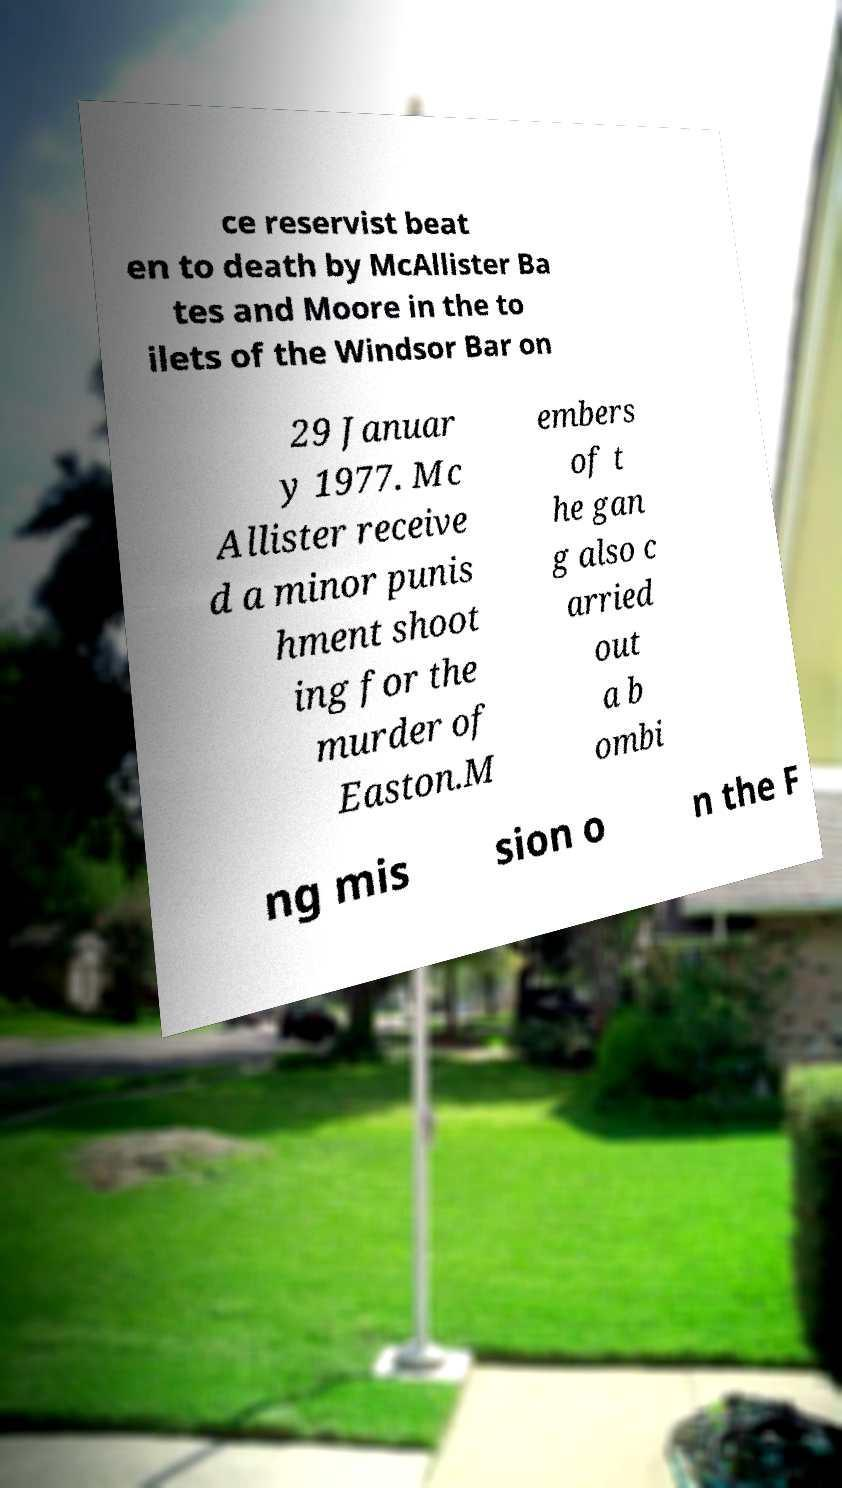Could you assist in decoding the text presented in this image and type it out clearly? ce reservist beat en to death by McAllister Ba tes and Moore in the to ilets of the Windsor Bar on 29 Januar y 1977. Mc Allister receive d a minor punis hment shoot ing for the murder of Easton.M embers of t he gan g also c arried out a b ombi ng mis sion o n the F 